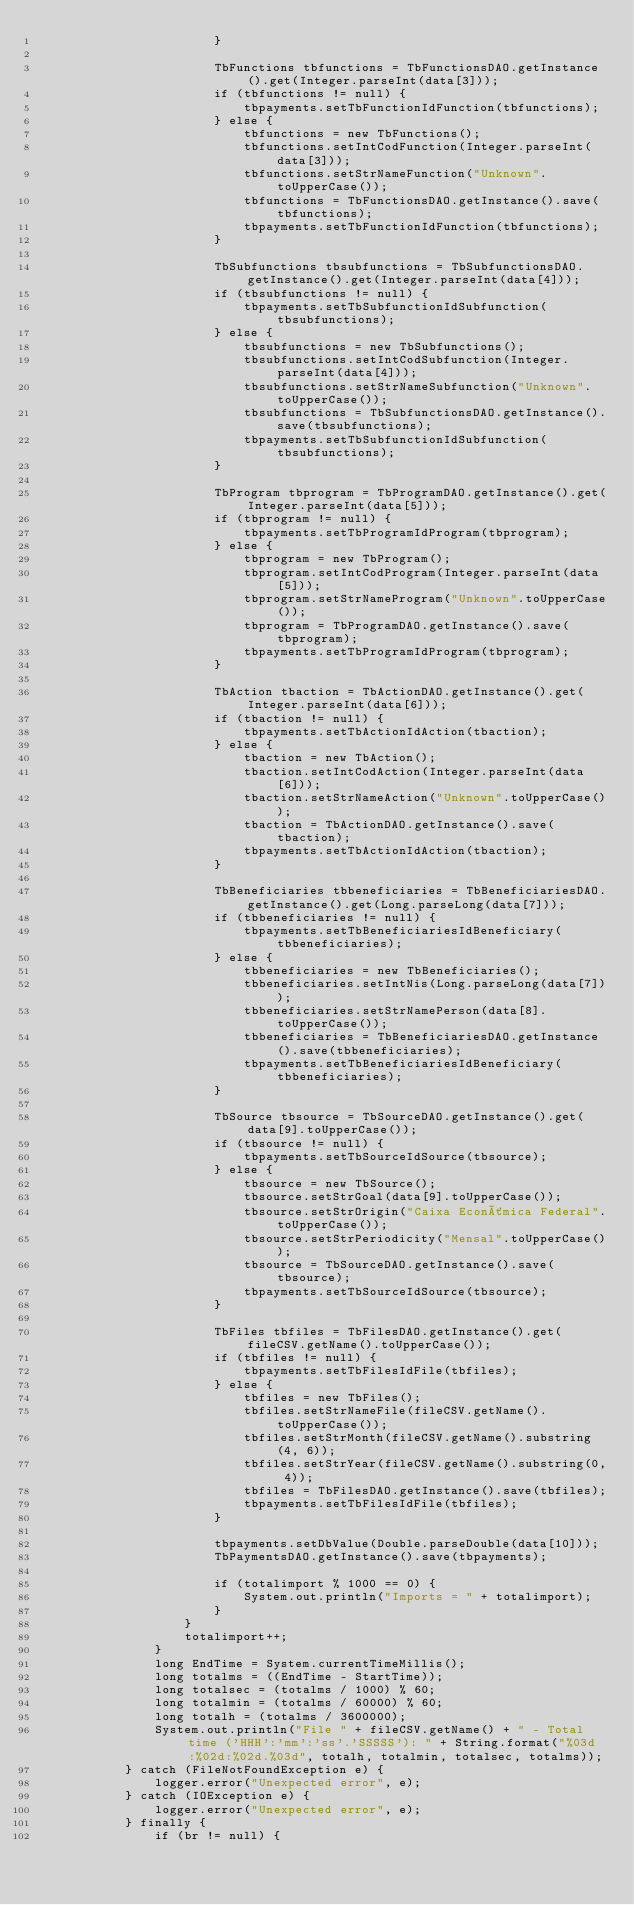Convert code to text. <code><loc_0><loc_0><loc_500><loc_500><_Java_>                        }

                        TbFunctions tbfunctions = TbFunctionsDAO.getInstance().get(Integer.parseInt(data[3]));
                        if (tbfunctions != null) {
                            tbpayments.setTbFunctionIdFunction(tbfunctions);
                        } else {
                            tbfunctions = new TbFunctions();
                            tbfunctions.setIntCodFunction(Integer.parseInt(data[3]));
                            tbfunctions.setStrNameFunction("Unknown".toUpperCase());
                            tbfunctions = TbFunctionsDAO.getInstance().save(tbfunctions);
                            tbpayments.setTbFunctionIdFunction(tbfunctions);
                        }

                        TbSubfunctions tbsubfunctions = TbSubfunctionsDAO.getInstance().get(Integer.parseInt(data[4]));
                        if (tbsubfunctions != null) {
                            tbpayments.setTbSubfunctionIdSubfunction(tbsubfunctions);
                        } else {
                            tbsubfunctions = new TbSubfunctions();
                            tbsubfunctions.setIntCodSubfunction(Integer.parseInt(data[4]));
                            tbsubfunctions.setStrNameSubfunction("Unknown".toUpperCase());
                            tbsubfunctions = TbSubfunctionsDAO.getInstance().save(tbsubfunctions);
                            tbpayments.setTbSubfunctionIdSubfunction(tbsubfunctions);
                        }

                        TbProgram tbprogram = TbProgramDAO.getInstance().get(Integer.parseInt(data[5]));
                        if (tbprogram != null) {
                            tbpayments.setTbProgramIdProgram(tbprogram);
                        } else {
                            tbprogram = new TbProgram();
                            tbprogram.setIntCodProgram(Integer.parseInt(data[5]));
                            tbprogram.setStrNameProgram("Unknown".toUpperCase());
                            tbprogram = TbProgramDAO.getInstance().save(tbprogram);
                            tbpayments.setTbProgramIdProgram(tbprogram);
                        }

                        TbAction tbaction = TbActionDAO.getInstance().get(Integer.parseInt(data[6]));
                        if (tbaction != null) {
                            tbpayments.setTbActionIdAction(tbaction);
                        } else {
                            tbaction = new TbAction();
                            tbaction.setIntCodAction(Integer.parseInt(data[6]));
                            tbaction.setStrNameAction("Unknown".toUpperCase());
                            tbaction = TbActionDAO.getInstance().save(tbaction);
                            tbpayments.setTbActionIdAction(tbaction);
                        }

                        TbBeneficiaries tbbeneficiaries = TbBeneficiariesDAO.getInstance().get(Long.parseLong(data[7]));
                        if (tbbeneficiaries != null) {
                            tbpayments.setTbBeneficiariesIdBeneficiary(tbbeneficiaries);
                        } else {
                            tbbeneficiaries = new TbBeneficiaries();
                            tbbeneficiaries.setIntNis(Long.parseLong(data[7]));
                            tbbeneficiaries.setStrNamePerson(data[8].toUpperCase());
                            tbbeneficiaries = TbBeneficiariesDAO.getInstance().save(tbbeneficiaries);
                            tbpayments.setTbBeneficiariesIdBeneficiary(tbbeneficiaries);
                        }

                        TbSource tbsource = TbSourceDAO.getInstance().get(data[9].toUpperCase());
                        if (tbsource != null) {
                            tbpayments.setTbSourceIdSource(tbsource);
                        } else {
                            tbsource = new TbSource();
                            tbsource.setStrGoal(data[9].toUpperCase());
                            tbsource.setStrOrigin("Caixa Econômica Federal".toUpperCase());
                            tbsource.setStrPeriodicity("Mensal".toUpperCase());
                            tbsource = TbSourceDAO.getInstance().save(tbsource);
                            tbpayments.setTbSourceIdSource(tbsource);
                        }

                        TbFiles tbfiles = TbFilesDAO.getInstance().get(fileCSV.getName().toUpperCase());
                        if (tbfiles != null) {
                            tbpayments.setTbFilesIdFile(tbfiles);
                        } else {
                            tbfiles = new TbFiles();
                            tbfiles.setStrNameFile(fileCSV.getName().toUpperCase());
                            tbfiles.setStrMonth(fileCSV.getName().substring(4, 6));
                            tbfiles.setStrYear(fileCSV.getName().substring(0, 4));
                            tbfiles = TbFilesDAO.getInstance().save(tbfiles);
                            tbpayments.setTbFilesIdFile(tbfiles);
                        }

                        tbpayments.setDbValue(Double.parseDouble(data[10]));
                        TbPaymentsDAO.getInstance().save(tbpayments);

                        if (totalimport % 1000 == 0) {
                            System.out.println("Imports = " + totalimport);
                        }
                    }
                    totalimport++;
                }
                long EndTime = System.currentTimeMillis();
                long totalms = ((EndTime - StartTime));
                long totalsec = (totalms / 1000) % 60;
                long totalmin = (totalms / 60000) % 60;
                long totalh = (totalms / 3600000);
                System.out.println("File " + fileCSV.getName() + " - Total time ('HHH':'mm':'ss'.'SSSSS'): " + String.format("%03d:%02d:%02d.%03d", totalh, totalmin, totalsec, totalms));
            } catch (FileNotFoundException e) {
                logger.error("Unexpected error", e);
            } catch (IOException e) {
                logger.error("Unexpected error", e);
            } finally {
                if (br != null) {</code> 